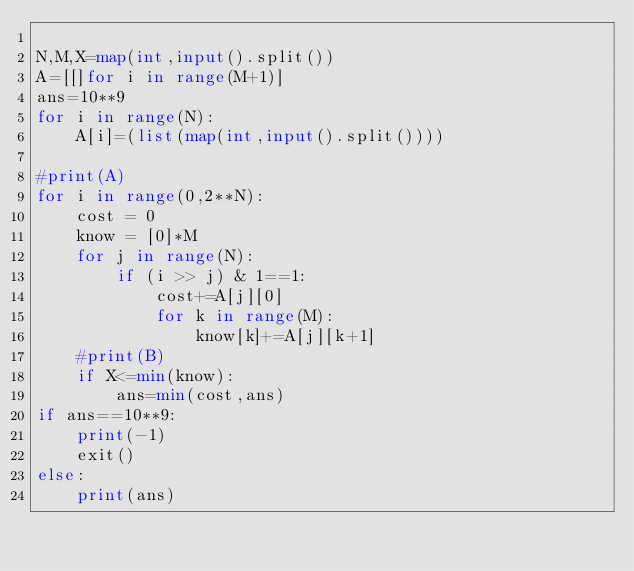Convert code to text. <code><loc_0><loc_0><loc_500><loc_500><_Python_>
N,M,X=map(int,input().split())
A=[[]for i in range(M+1)]
ans=10**9
for i in range(N):
    A[i]=(list(map(int,input().split())))

#print(A)
for i in range(0,2**N):
    cost = 0
    know = [0]*M
    for j in range(N):
        if (i >> j) & 1==1:
            cost+=A[j][0]
            for k in range(M):
                know[k]+=A[j][k+1]
    #print(B)
    if X<=min(know):
        ans=min(cost,ans)
if ans==10**9:
    print(-1)
    exit()
else:
    print(ans)
</code> 